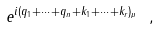Convert formula to latex. <formula><loc_0><loc_0><loc_500><loc_500>e ^ { i ( q _ { 1 } + \dots + q _ { n } + k _ { 1 } + \dots + k _ { r } ) _ { \mu } } \ ,</formula> 